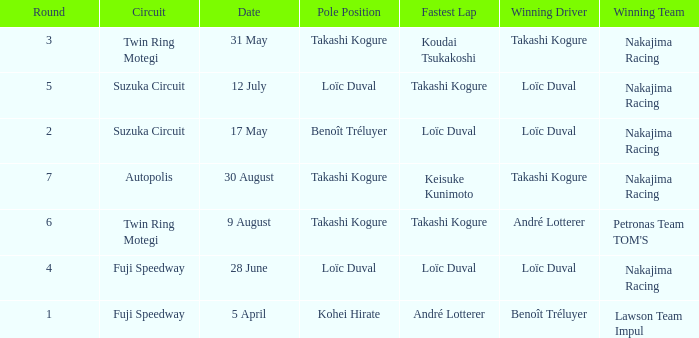Who has the fastest lap where Benoît Tréluyer got the pole position? Loïc Duval. 